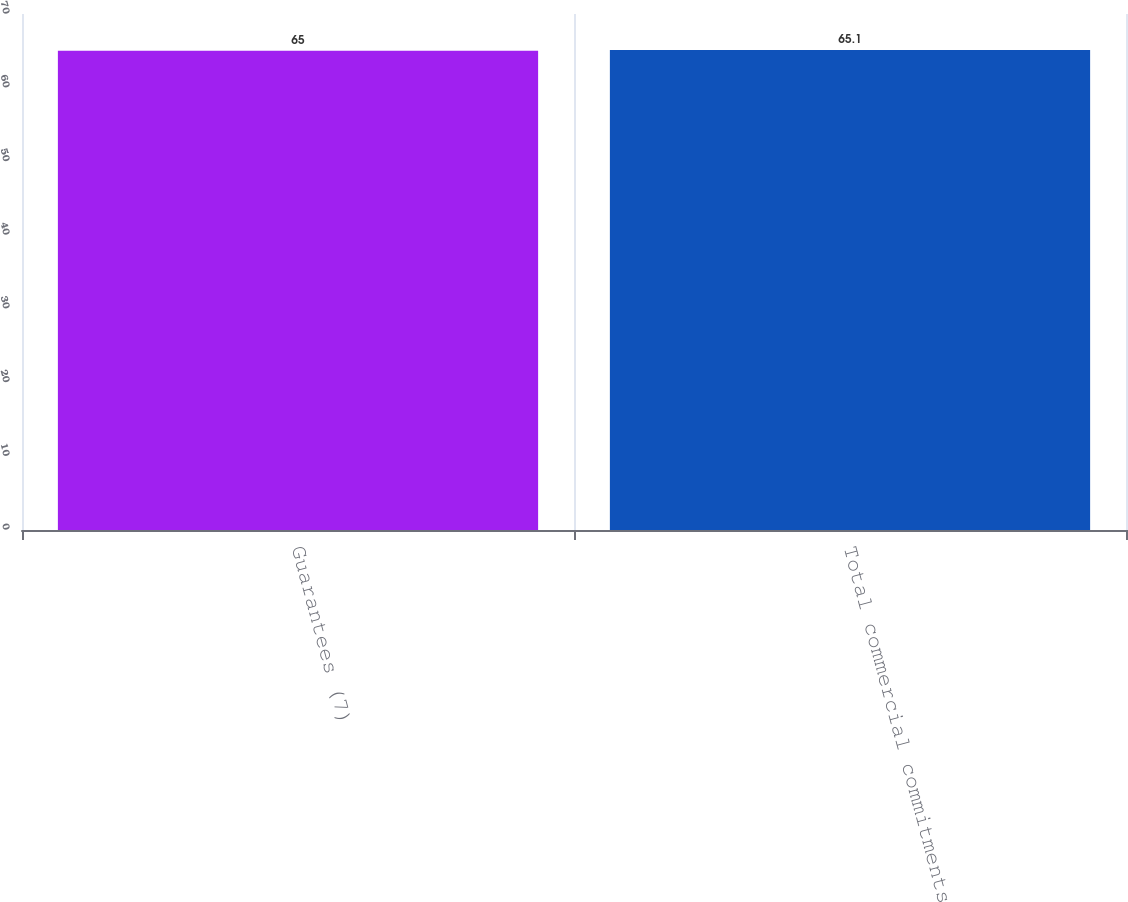<chart> <loc_0><loc_0><loc_500><loc_500><bar_chart><fcel>Guarantees (7)<fcel>Total commercial commitments<nl><fcel>65<fcel>65.1<nl></chart> 